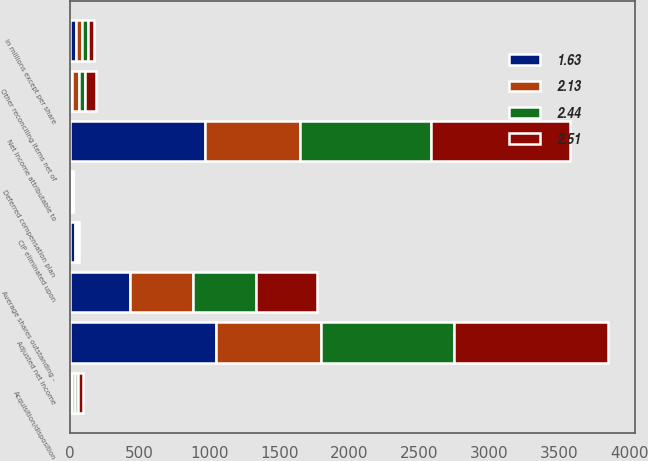Convert chart to OTSL. <chart><loc_0><loc_0><loc_500><loc_500><stacked_bar_chart><ecel><fcel>in millions except per share<fcel>Net income attributable to<fcel>CIP eliminated upon<fcel>Acquisition/disposition<fcel>Deferred compensation plan<fcel>Other reconciling items net of<fcel>Adjusted net income<fcel>Average shares outstanding -<nl><fcel>1.63<fcel>43.5<fcel>968.1<fcel>40.4<fcel>14<fcel>5.9<fcel>20.3<fcel>1048.7<fcel>429.3<nl><fcel>2.51<fcel>43.5<fcel>988.1<fcel>7.8<fcel>36.2<fcel>0.3<fcel>78.6<fcel>1094.8<fcel>435.6<nl><fcel>2.44<fcel>43.5<fcel>940.3<fcel>8.7<fcel>23.8<fcel>12.6<fcel>40.7<fcel>953.3<fcel>448.5<nl><fcel>2.13<fcel>43.5<fcel>677.1<fcel>10.7<fcel>21.9<fcel>7.4<fcel>46.3<fcel>748.6<fcel>453.8<nl></chart> 